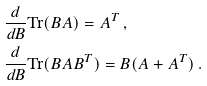<formula> <loc_0><loc_0><loc_500><loc_500>& \frac { d } { d B } \text {Tr} ( B A ) = A ^ { T } \, , \\ & \frac { d } { d B } \text {Tr} ( B A B ^ { T } ) = B ( A + A ^ { T } ) \, . \\</formula> 